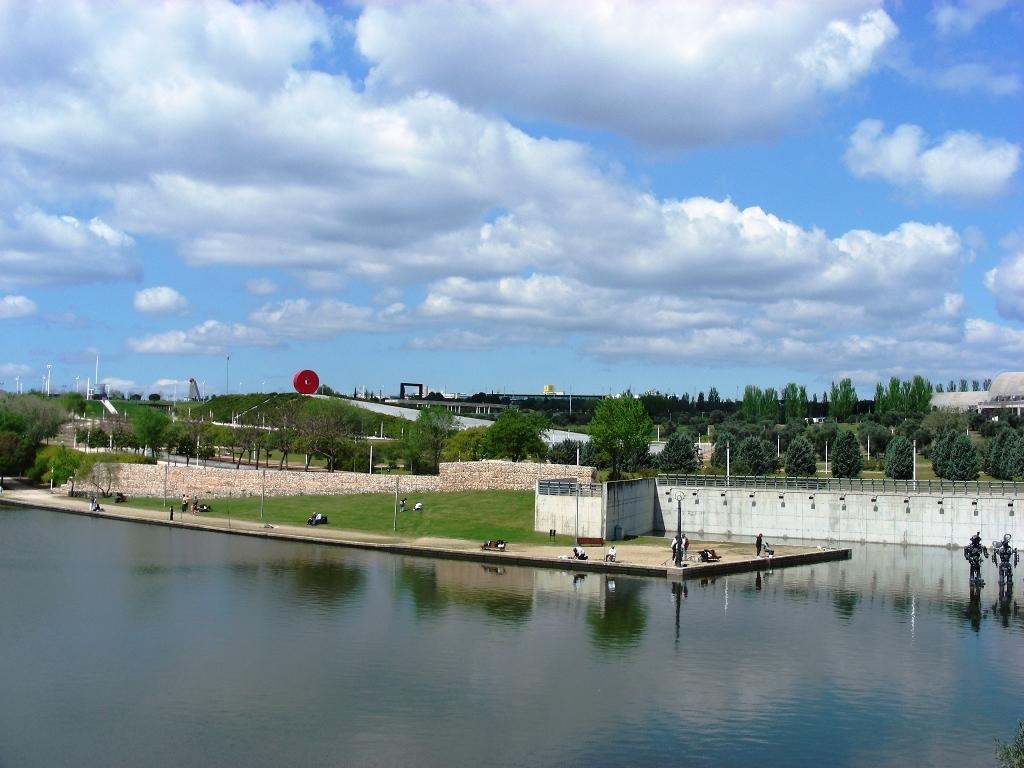How would you summarize this image in a sentence or two? In this image there is the water. To the right there are sculptures on the water. Beside the water there are poles and grass on the ground. There are people beside the water. In the background there are buildings and trees. At the top there is the sky. 